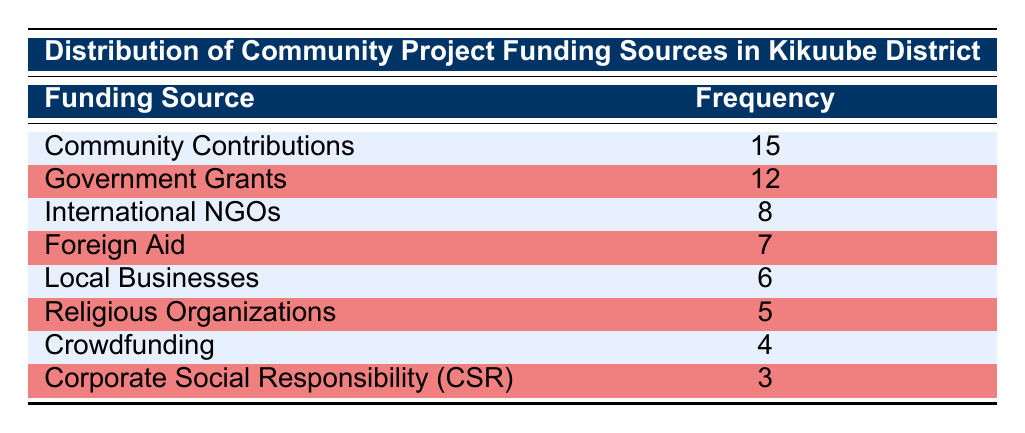What is the most frequent funding source for community projects in Kikuube District? The table indicates that "Community Contributions" has the highest frequency of 15, making it the most frequent funding source.
Answer: Community Contributions How many funding sources have a frequency of 7 or more? By counting the frequencies, we see that "Community Contributions" (15), "Government Grants" (12), "International NGOs" (8), and "Foreign Aid" (7) all have frequencies of 7 or more. This totals 4 funding sources.
Answer: 4 What is the total frequency of all funding sources listed? To find the total frequency, we add together all the frequencies: 15 + 12 + 8 + 7 + 6 + 5 + 4 + 3 = 60.
Answer: 60 Is there a funding source with a frequency of 3? The table shows that "Corporate Social Responsibility (CSR)" has a frequency of 3, confirming that there is indeed such a funding source.
Answer: Yes What is the difference in frequency between the highest and the lowest funding sources? The highest frequency is 15 (Community Contributions) and the lowest is 3 (Corporate Social Responsibility). The difference is 15 - 3 = 12.
Answer: 12 What percentage of the total funding comes from "Local Businesses"? First, find the total frequency which is 60. The frequency for "Local Businesses" is 6. The percentage is calculated as (6/60) * 100 = 10%.
Answer: 10% Which funding source has a frequency between 4 and 8? From the table, "Foreign Aid" has a frequency of 7, which lies between 4 and 8. Therefore, the funding source that meets this criterion is "Foreign Aid."
Answer: Foreign Aid If you combine the frequencies of "International NGOs", "Foreign Aid", and "Religious Organizations," what is the total? Adding these frequencies together: 8 (International NGOs) + 7 (Foreign Aid) + 5 (Religious Organizations) gives us a total of 20.
Answer: 20 Which funding source has the smallest frequency and what is that frequency? Looking at the table, "Corporate Social Responsibility (CSR)" has the smallest frequency, which is 3.
Answer: Corporate Social Responsibility (CSR), 3 